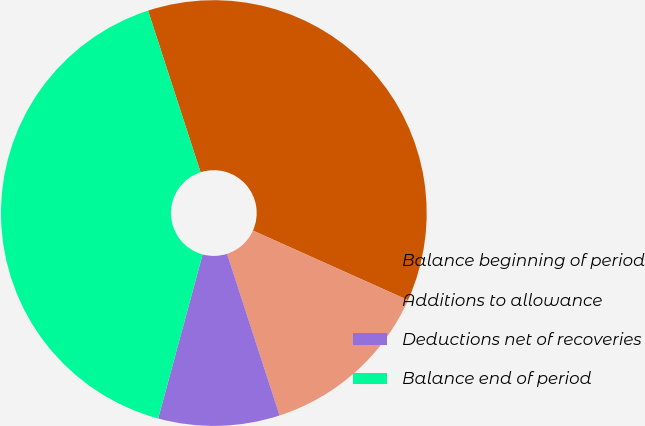Convert chart to OTSL. <chart><loc_0><loc_0><loc_500><loc_500><pie_chart><fcel>Balance beginning of period<fcel>Additions to allowance<fcel>Deductions net of recoveries<fcel>Balance end of period<nl><fcel>36.71%<fcel>13.29%<fcel>9.21%<fcel>40.79%<nl></chart> 